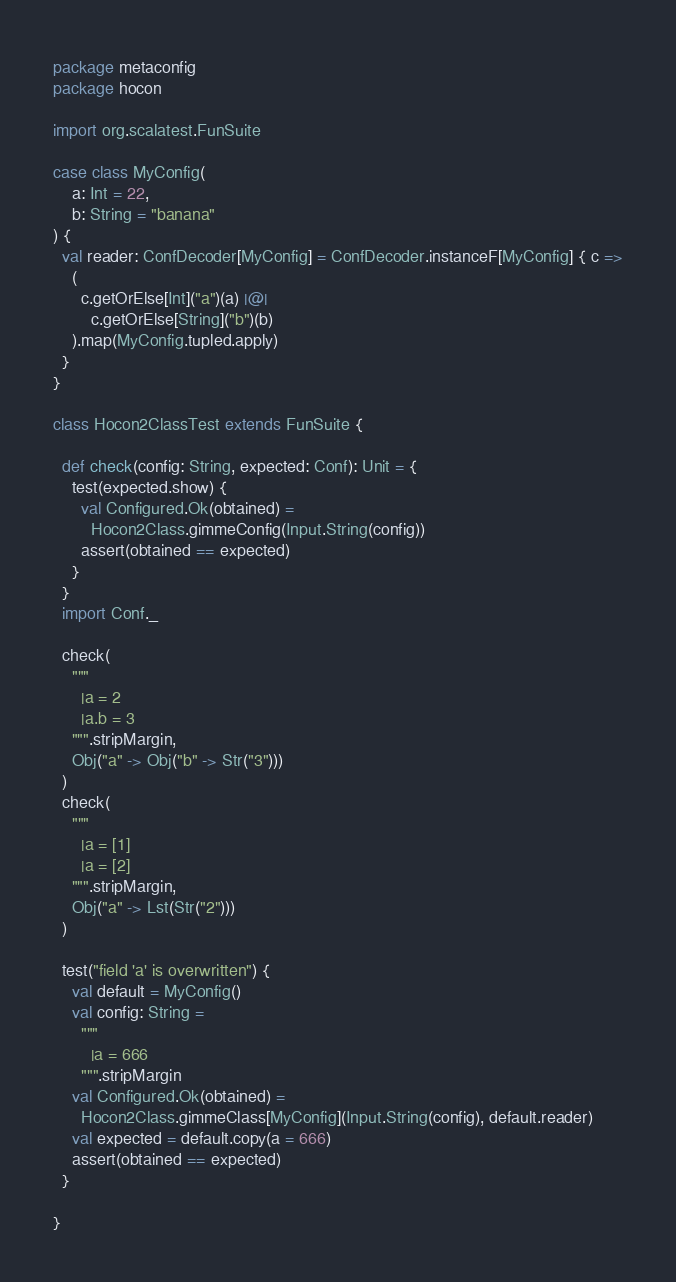Convert code to text. <code><loc_0><loc_0><loc_500><loc_500><_Scala_>package metaconfig
package hocon

import org.scalatest.FunSuite

case class MyConfig(
    a: Int = 22,
    b: String = "banana"
) {
  val reader: ConfDecoder[MyConfig] = ConfDecoder.instanceF[MyConfig] { c =>
    (
      c.getOrElse[Int]("a")(a) |@|
        c.getOrElse[String]("b")(b)
    ).map(MyConfig.tupled.apply)
  }
}

class Hocon2ClassTest extends FunSuite {

  def check(config: String, expected: Conf): Unit = {
    test(expected.show) {
      val Configured.Ok(obtained) =
        Hocon2Class.gimmeConfig(Input.String(config))
      assert(obtained == expected)
    }
  }
  import Conf._

  check(
    """
      |a = 2
      |a.b = 3
    """.stripMargin,
    Obj("a" -> Obj("b" -> Str("3")))
  )
  check(
    """
      |a = [1]
      |a = [2]
    """.stripMargin,
    Obj("a" -> Lst(Str("2")))
  )

  test("field 'a' is overwritten") {
    val default = MyConfig()
    val config: String =
      """
        |a = 666
      """.stripMargin
    val Configured.Ok(obtained) =
      Hocon2Class.gimmeClass[MyConfig](Input.String(config), default.reader)
    val expected = default.copy(a = 666)
    assert(obtained == expected)
  }

}
</code> 